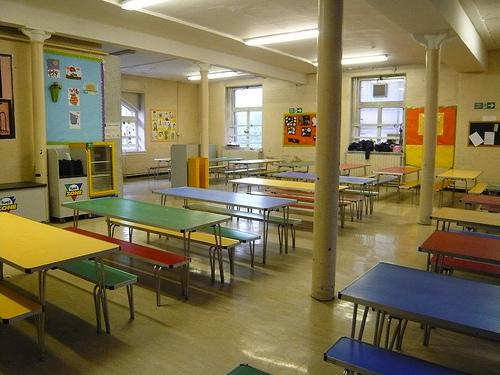Explain what the wall decorations on this image are. The wall has decorations hung up, but there is no specific description of what those decorations look like. Provide a brief description of the setting within the image. The image shows a room with various colored tables and benches, a white floor, and a white post. It appears to be a cafeteria. Is there any information about the state of the window in the picture? Yes, the window is closed. How can you describe the floor based on the given information? The floor is white and shiny. What can you say about the tables in the cafeteria? The tables are rectangular, different colors, and placed in various positions within the room. Identify the color of the table at the top left corner of the image. The table at the top left corner is yellow. Count the number of colored tables in the cafeteria. There are 9 colored tables in the cafeteria. What material is mentioned in the image regarding the columns? The columns are made of metal. How many total tables and benches are in the image? There are 5 tables and 4 benches. Look at the large round table in the center of the room. All the described tables are rectangular, not round. Moreover, there's no mention of a table being in the center of the room. This instruction is misleading as it inaccurately describes the shape and location of the tables. Can you find the purple chair next to the yellow table? No, it's not mentioned in the image. 